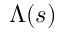Convert formula to latex. <formula><loc_0><loc_0><loc_500><loc_500>\Lambda ( s )</formula> 